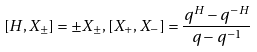<formula> <loc_0><loc_0><loc_500><loc_500>[ H , X _ { \pm } ] = \pm X _ { \pm } , [ X _ { + } , X _ { - } ] = \frac { q ^ { H } - q ^ { - H } } { q - q ^ { - 1 } }</formula> 